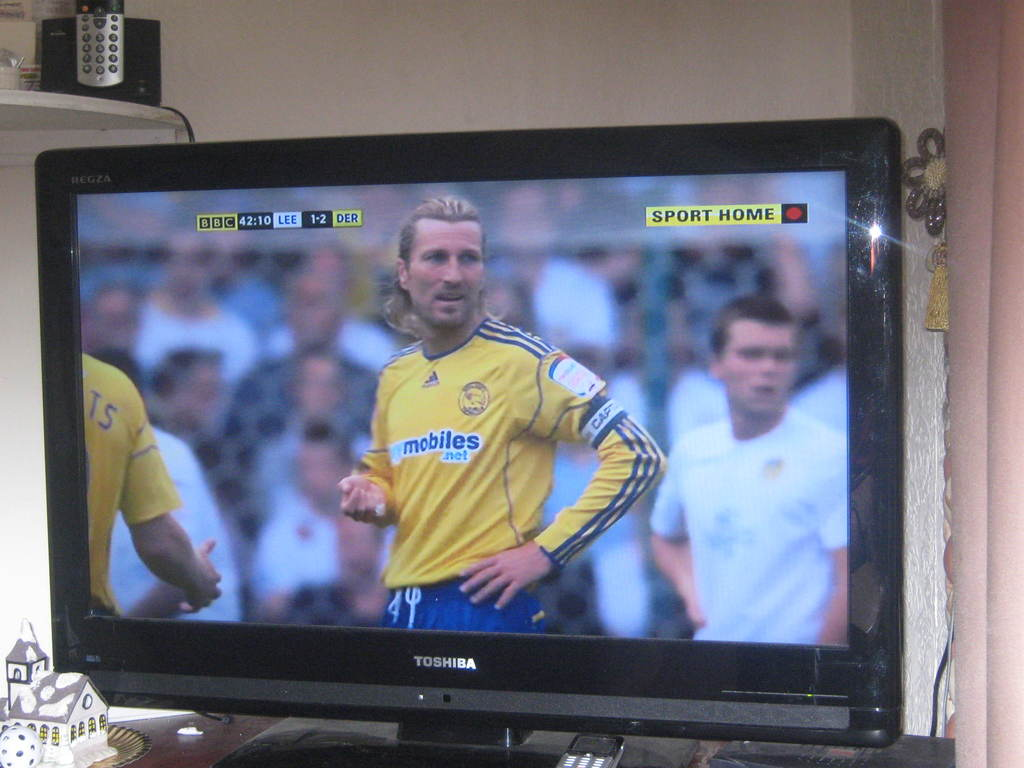Provide a one-sentence caption for the provided image. The image shows a Toshiba television broadcasting a soccer match between Leeds United and Derby County, as indicated by the score 'LEE 1-2 DER' on the BBC channel, capturing a moment of the game at 42:10. 